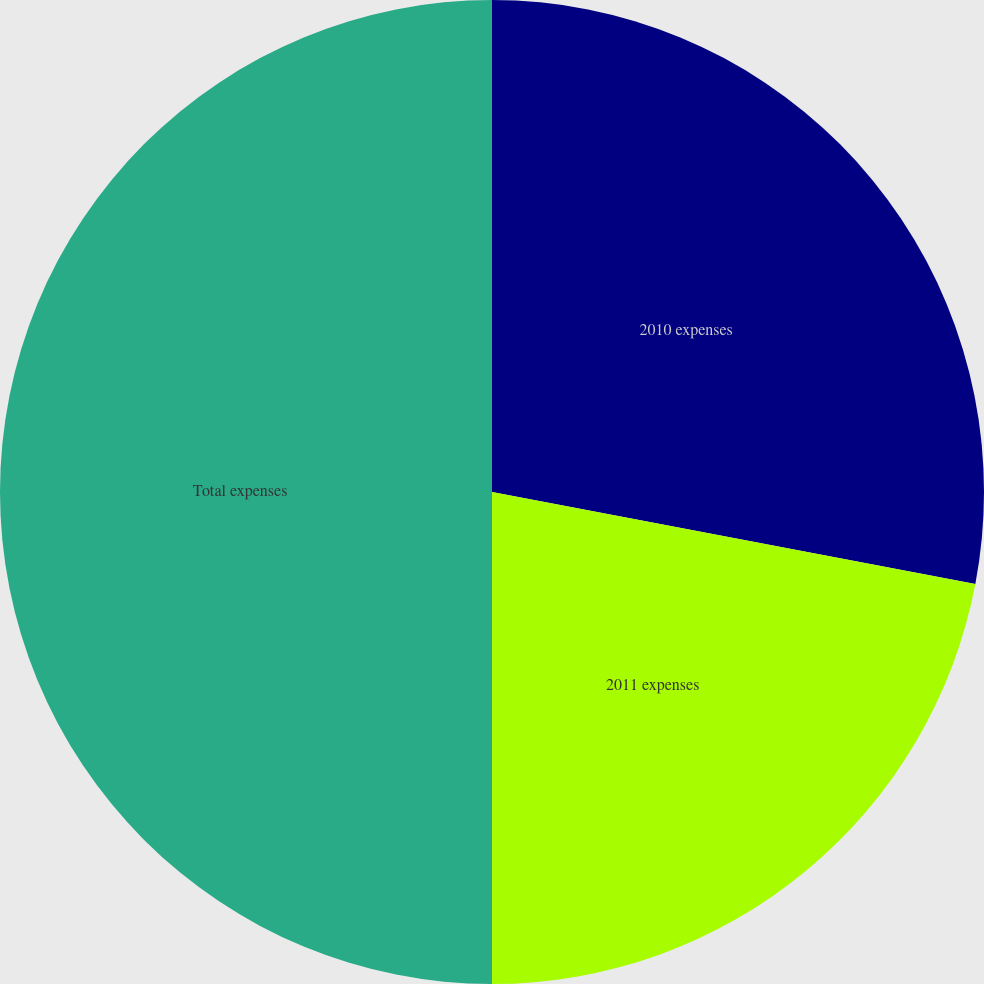Convert chart. <chart><loc_0><loc_0><loc_500><loc_500><pie_chart><fcel>2010 expenses<fcel>2011 expenses<fcel>Total expenses<nl><fcel>27.99%<fcel>22.01%<fcel>50.0%<nl></chart> 